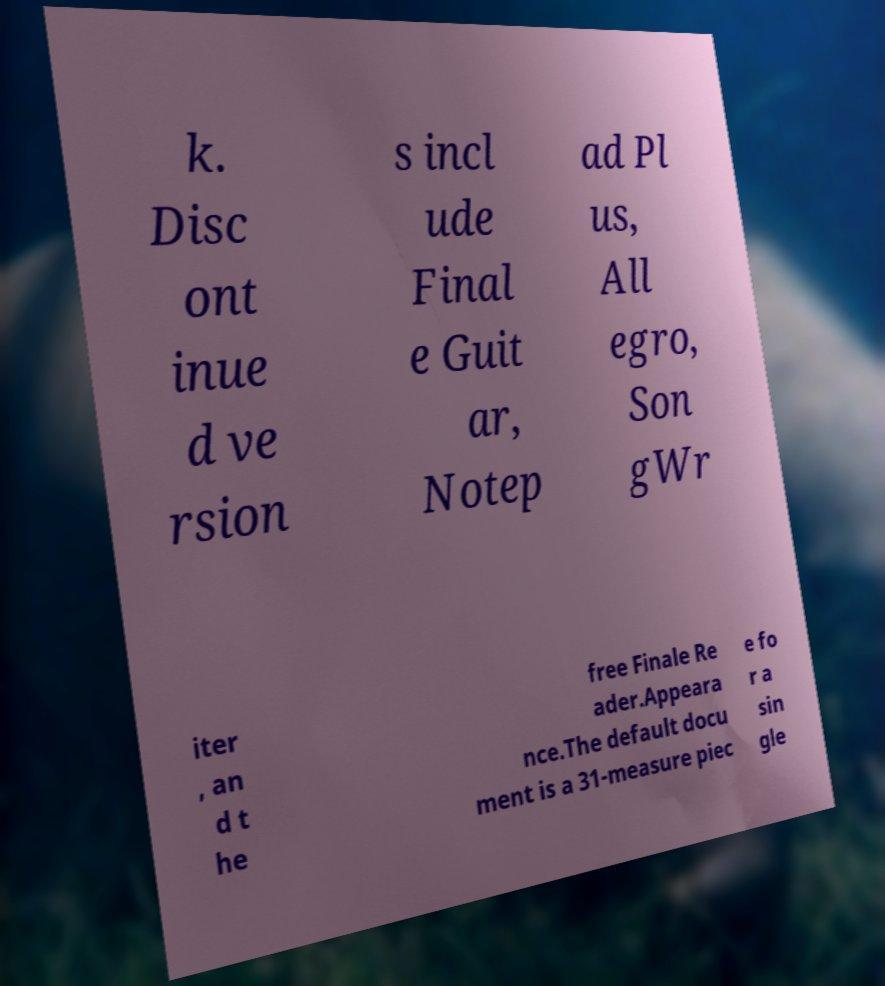I need the written content from this picture converted into text. Can you do that? k. Disc ont inue d ve rsion s incl ude Final e Guit ar, Notep ad Pl us, All egro, Son gWr iter , an d t he free Finale Re ader.Appeara nce.The default docu ment is a 31-measure piec e fo r a sin gle 